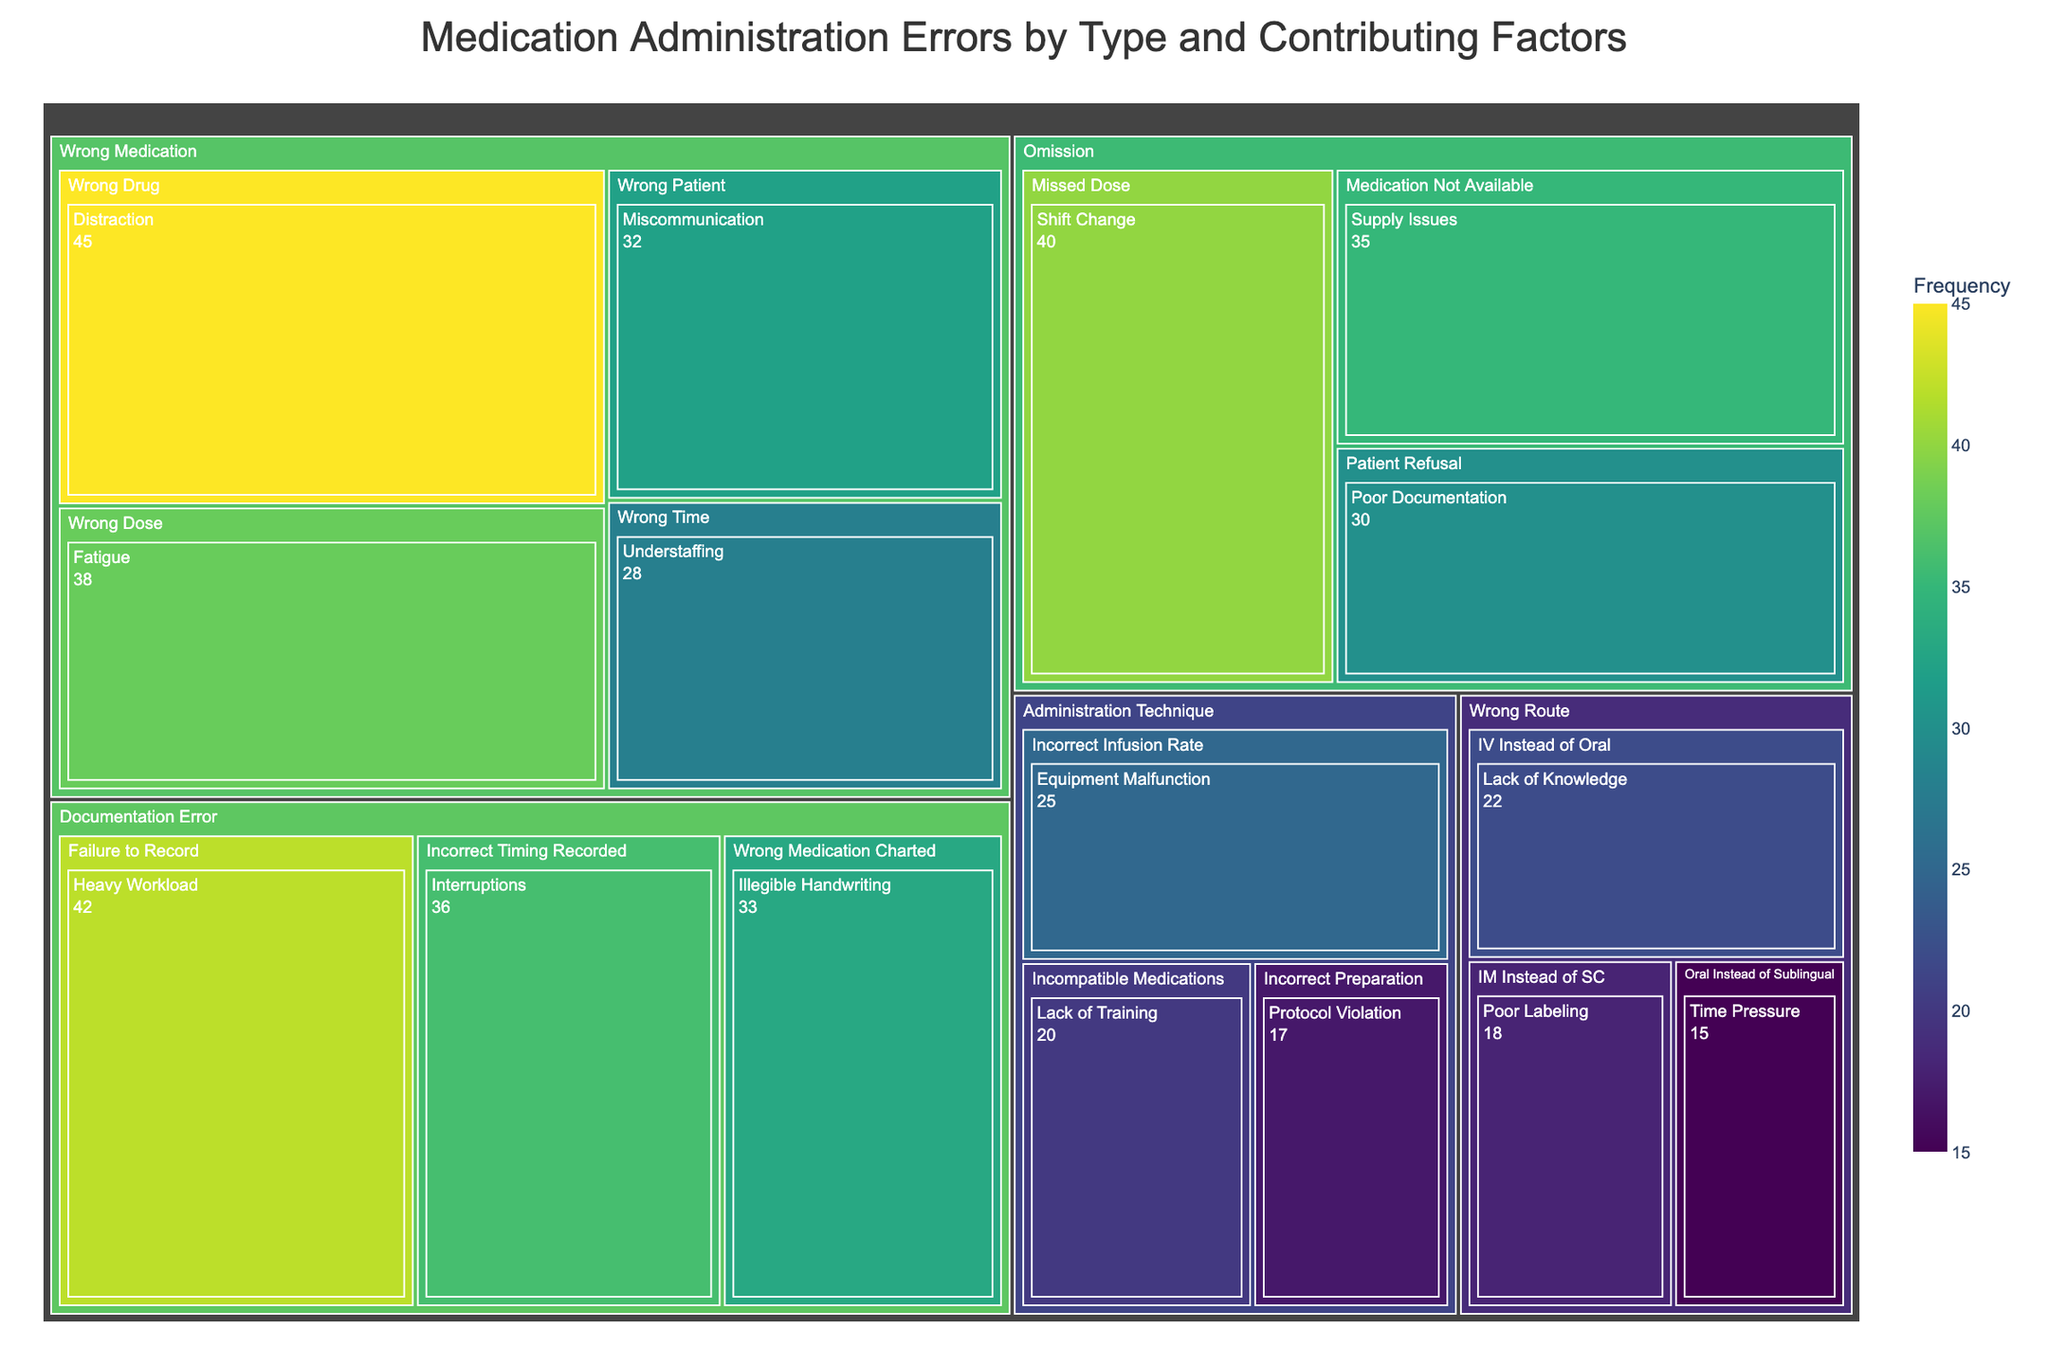What is the title of the treemap? The title is typically located at the top of the figure and provides a summary of what the treemap represents.
Answer: Medication Administration Errors by Type and Contributing Factors Which category has the highest frequency of errors? The largest colored area in the treemap should belong to the category with the highest sum of frequencies.
Answer: Wrong Medication How many frequencies are attributed to "Documentation Error"? Sum all frequency values associated with the "Documentation Error" category. 42 + 36 + 33 = 111
Answer: 111 Which type of error is most frequently associated with the "Distraction" contributing factor? Locate the "Distraction" factor and see its respective parent error type.
Answer: Wrong Drug How does the frequency of "Fatigue" contributing to "Wrong Dose" compare to "Poor Documentation" contributing to "Patient Refusal"? Compare the two specified frequency values. Fatigue (38) vs. Poor Documentation (30).
Answer: Fatigue contributing to Wrong Dose is greater What is the total frequency of errors related to "Omission"? Add up the frequencies of all types under "Omission". 40 + 35 + 30 = 105
Answer: 105 Which category has the least number of types associated with it? Count the number of types for each category and identify the one with the least.
Answer: Wrong Route Between "Understaffing" and "Time Pressure," which contributing factor has a higher frequency, and by how much? Compare the frequencies: Understaffing (28) vs. Time Pressure (15). Subtract the smaller from the larger.
Answer: Understaffing by 13 What is the most frequent error type under the "Administration Technique" category? Identify the error type with the highest frequency within the "Administration Technique" category.
Answer: Incorrect Infusion Rate How does the frequency of "Shift Change" contributing to "Missed Dose" compare to "Heavy Workload" contributing to "Failure to Record"? Compare the two specified frequency values. Shift Change (40) vs. Heavy Workload (42).
Answer: Heavy Workload contributing to Failure to Record is greater 